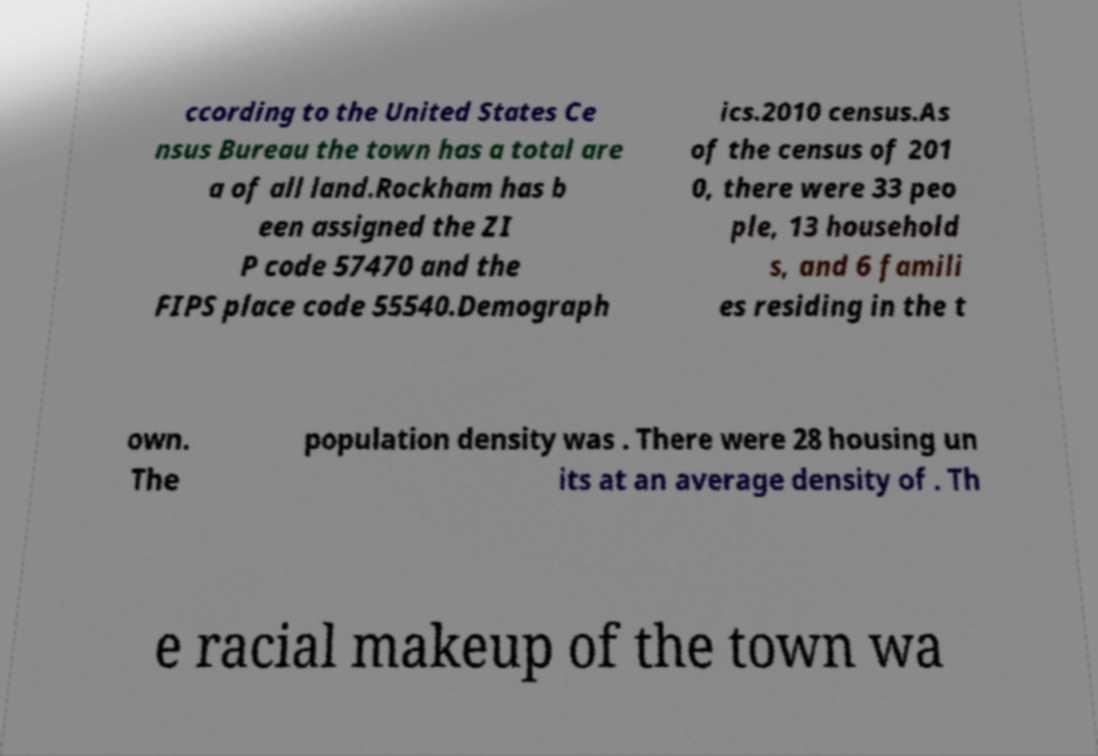Can you read and provide the text displayed in the image?This photo seems to have some interesting text. Can you extract and type it out for me? ccording to the United States Ce nsus Bureau the town has a total are a of all land.Rockham has b een assigned the ZI P code 57470 and the FIPS place code 55540.Demograph ics.2010 census.As of the census of 201 0, there were 33 peo ple, 13 household s, and 6 famili es residing in the t own. The population density was . There were 28 housing un its at an average density of . Th e racial makeup of the town wa 